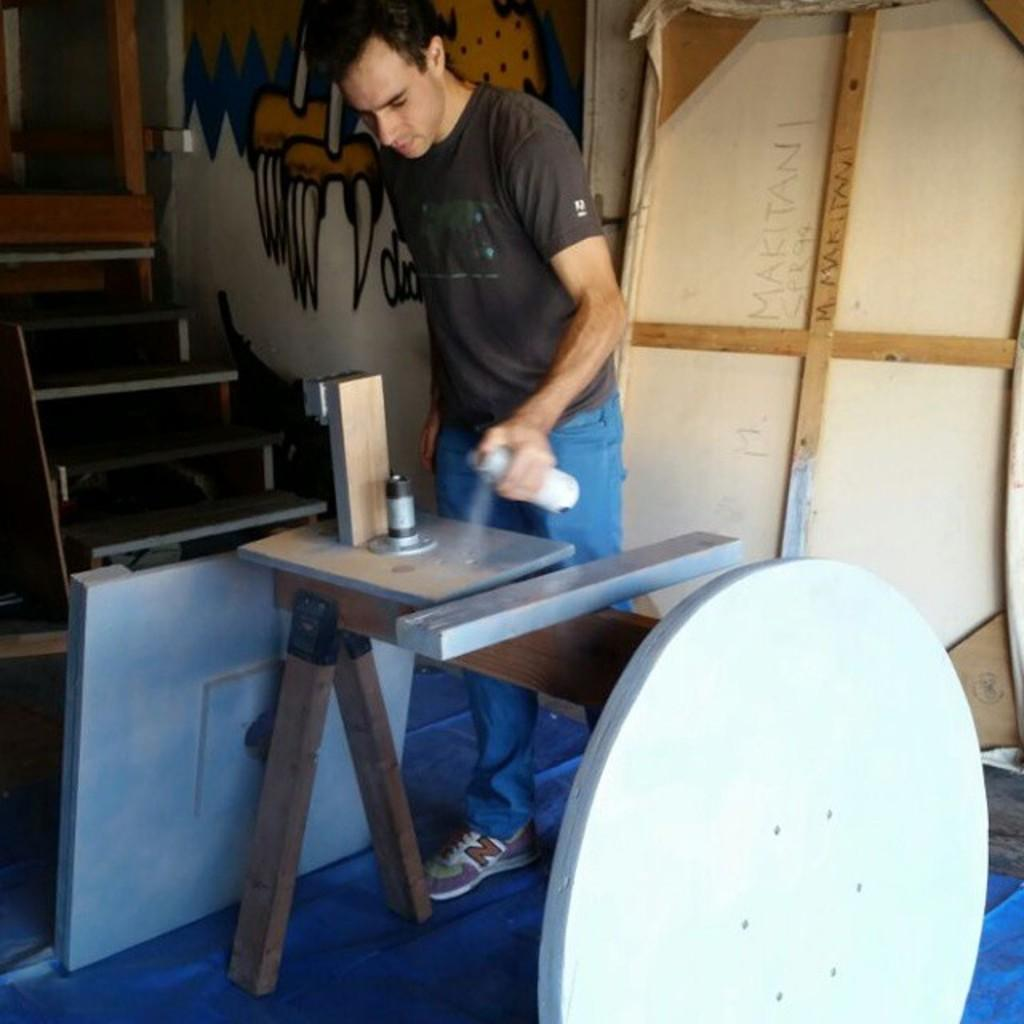Who is the person in the image? There is a man in the image. What is the man doing in the image? The man is spraying paint. What is the paint being applied to? The paint is being applied to a metal object. What type of celery is the man using to spray paint in the image? There is no celery present in the image; the man is using a spray paint can to apply paint to the metal object. 